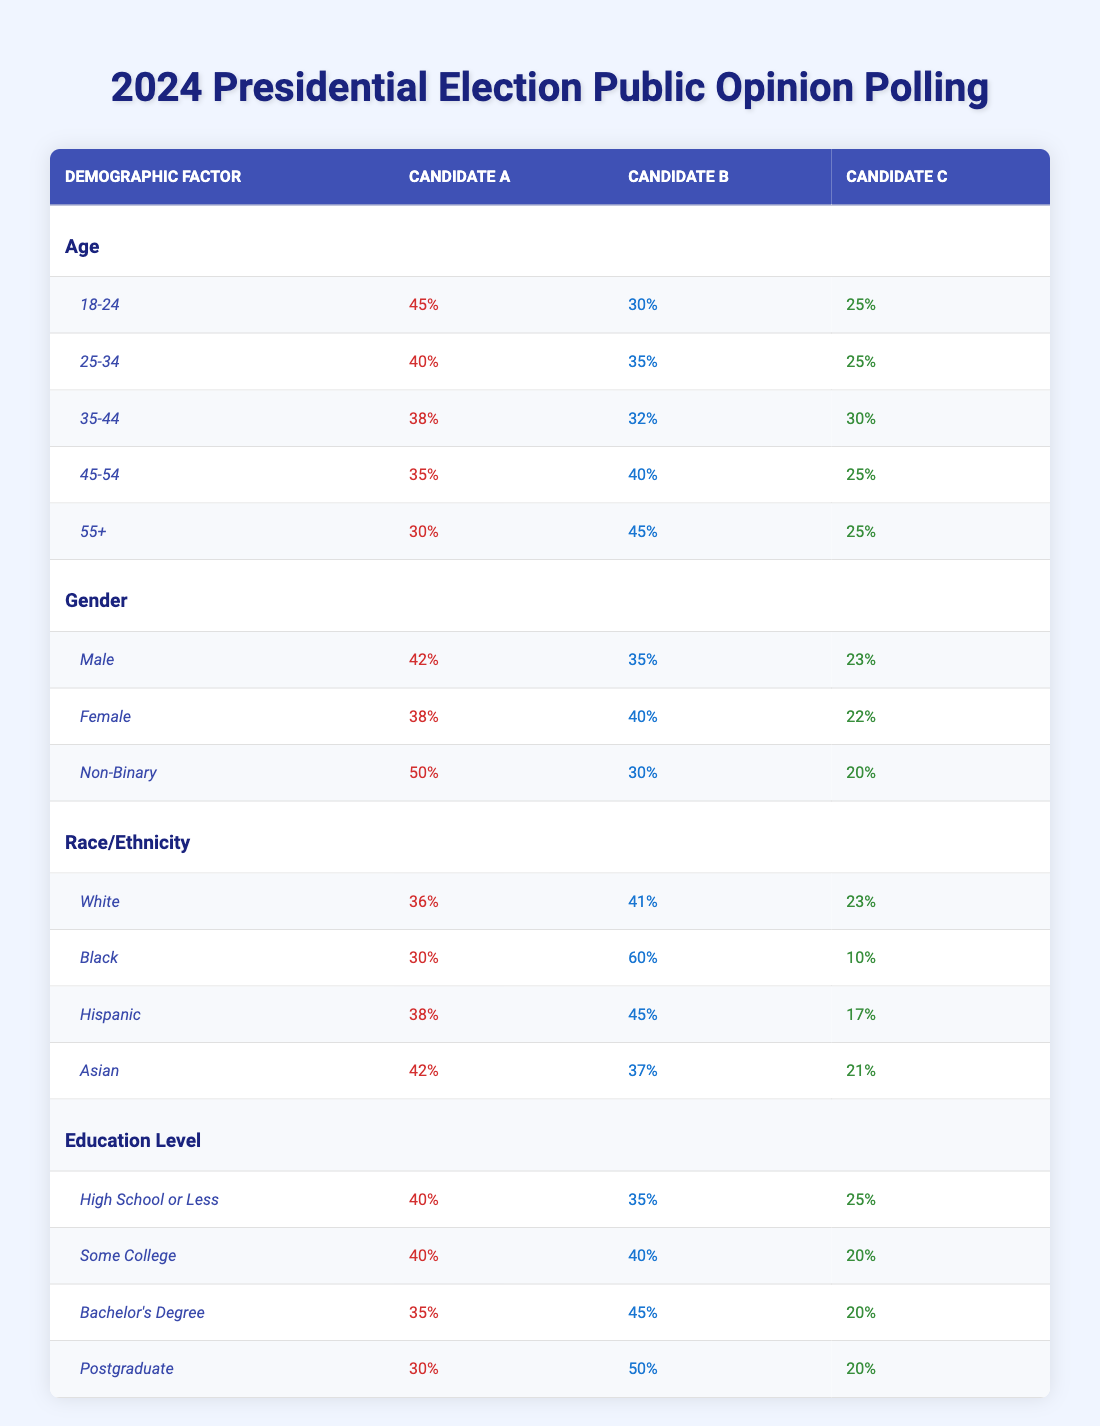What percentage of 18-24 age group supports Candidate A? According to the table, the percentage of the 18-24 age group that supports Candidate A is stated directly in the row for that age group, which shows a support of 45%.
Answer: 45% Who has the highest support among Black voters? The table shows that Candidate B has the highest support among Black voters, with a support percentage of 60% listed in the row for the Black demographic.
Answer: Candidate B What is the difference in support for Candidate B between the 25-34 and 45-54 age groups? From the table, Candidate B's support in the 25-34 age group is 35% and in the 45-54 age group is 40%. The difference is calculated as 40% - 35% = 5%.
Answer: 5% Is Candidate C more popular among Females or Non-Binary individuals? Examining the table, Candidate C has 22% support from Females and 20% from Non-Binary individuals. Since 22% is greater than 20%, Candidate C is more popular among Females.
Answer: Yes What is the average support for Candidate A across all age groups? The percentages for Candidate A in the age groups are: 45%, 40%, 38%, 35%, and 30%. To calculate the average, sum these values: 45 + 40 + 38 + 35 + 30 = 188. Then, divide by the number of age groups (5), giving an average of 188/5 = 37.6%.
Answer: 37.6% Which candidate has the lowest support among Hispanic voters? Referring to the table, Candidate C has a support of 17% among Hispanic voters, which is the lowest compared to Candidate A (38%) and Candidate B (45%).
Answer: Candidate C What is the combined support for Candidate B among the 55+ age group and Non-Binary individuals? For the 55+ age group, Candidate B has 45% support, and for Non-Binary individuals, Candidate B has 30% support. Adding these gives 45% + 30% = 75% combined support.
Answer: 75% Does higher education correlate with higher support for Candidate B? Looking at education levels for Candidate B: High School or Less (35%), Some College (40%), Bachelor's Degree (45%), and Postgraduate (50%). Since support increases as education level increases, we can conclude that higher education correlates with higher support for Candidate B.
Answer: Yes What percentage of Male voters support Candidate A? In the table, the percentage of Male voters who support Candidate A is directly given as 42%.
Answer: 42% 